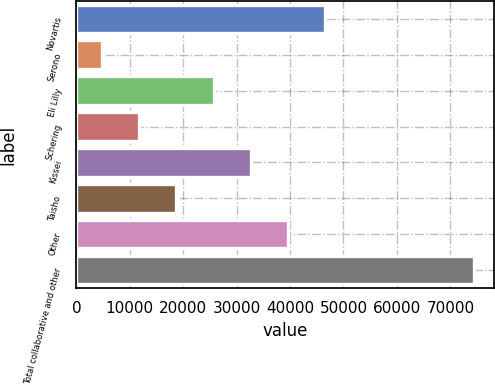<chart> <loc_0><loc_0><loc_500><loc_500><bar_chart><fcel>Novartis<fcel>Serono<fcel>Eli Lilly<fcel>Schering<fcel>Kissei<fcel>Taisho<fcel>Other<fcel>Total collaborative and other<nl><fcel>46629.2<fcel>4802<fcel>25715.6<fcel>11773.2<fcel>32686.8<fcel>18744.4<fcel>39658<fcel>74514<nl></chart> 